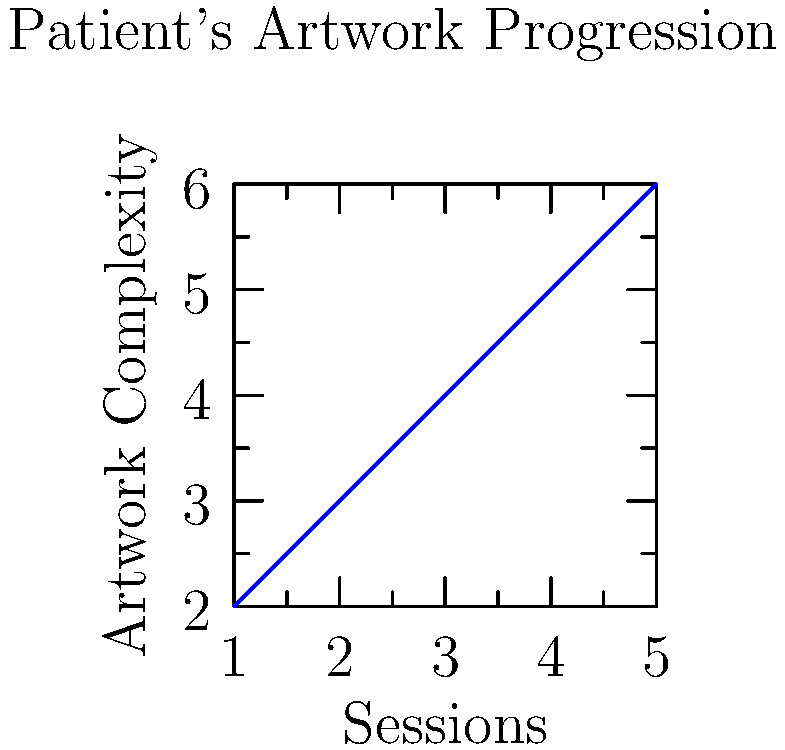Based on the graph showing a patient's artwork progression in art therapy sessions, what qualitative observation can be made about the patient's emotional expression over time, and how might this information be used in conjunction with other therapeutic methods? 1. Observe the graph: The x-axis represents the number of therapy sessions, while the y-axis represents the complexity of the artwork.

2. Analyze the trend: The graph shows a clear upward trend, indicating that the complexity of the patient's artwork is increasing over time.

3. Interpret the trend: Increased complexity in artwork often suggests:
   a) Greater emotional expression
   b) Improved ability to communicate through art
   c) Potential increase in trust and comfort with the therapy process

4. Consider the limitations: As a traditional psychologist, it's important to note that this graph alone cannot provide a complete picture of the patient's progress.

5. Integrate with other methods: This information should be used in conjunction with:
   a) Verbal communication during sessions
   b) Behavioral observations
   c) Standardized psychological assessments

6. Formulate a holistic approach: The artwork progression can serve as one piece of evidence in a broader therapeutic assessment, informing treatment plans and providing a basis for discussion with the patient.

7. Maintain a critical perspective: Remember that while the graph shows a clear trend, human behavior and emotions are complex and cannot be fully captured or predicted by quantitative measures alone.
Answer: Increased emotional expression; use as supplementary evidence in holistic assessment 